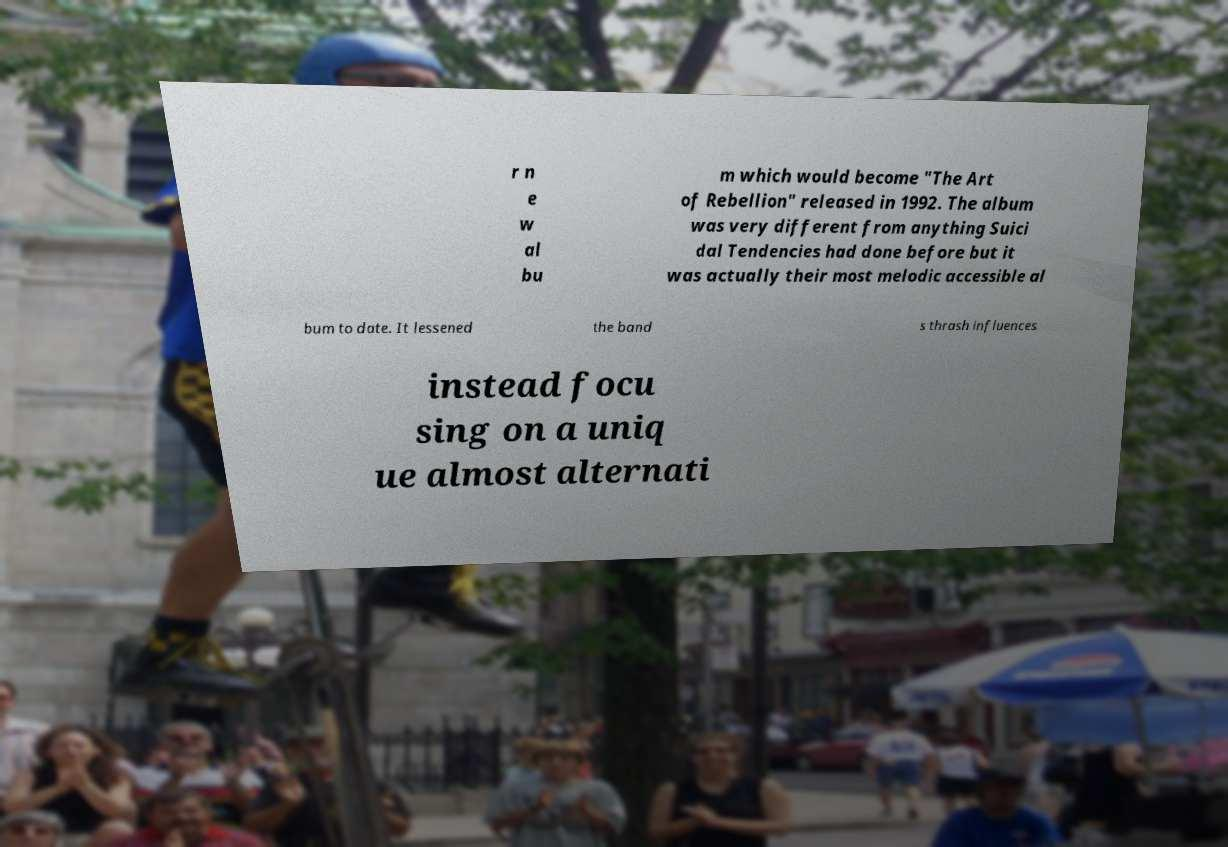Please read and relay the text visible in this image. What does it say? r n e w al bu m which would become "The Art of Rebellion" released in 1992. The album was very different from anything Suici dal Tendencies had done before but it was actually their most melodic accessible al bum to date. It lessened the band s thrash influences instead focu sing on a uniq ue almost alternati 